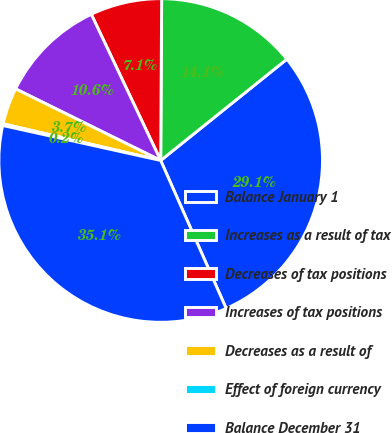<chart> <loc_0><loc_0><loc_500><loc_500><pie_chart><fcel>Balance January 1<fcel>Increases as a result of tax<fcel>Decreases of tax positions<fcel>Increases of tax positions<fcel>Decreases as a result of<fcel>Effect of foreign currency<fcel>Balance December 31<nl><fcel>29.14%<fcel>14.14%<fcel>7.15%<fcel>10.65%<fcel>3.66%<fcel>0.17%<fcel>35.1%<nl></chart> 